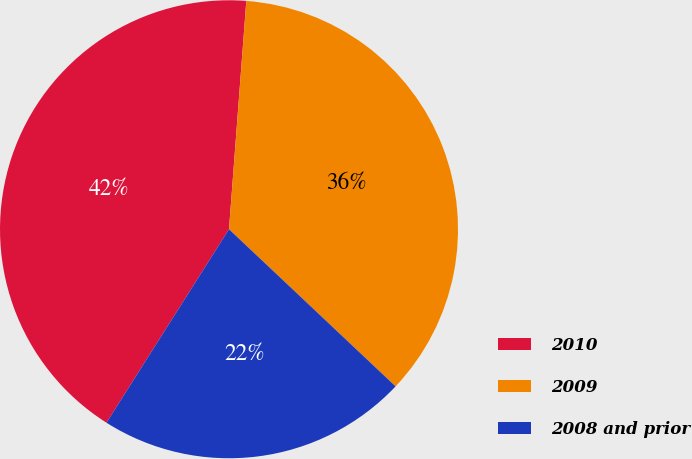<chart> <loc_0><loc_0><loc_500><loc_500><pie_chart><fcel>2010<fcel>2009<fcel>2008 and prior<nl><fcel>42.22%<fcel>35.83%<fcel>21.95%<nl></chart> 